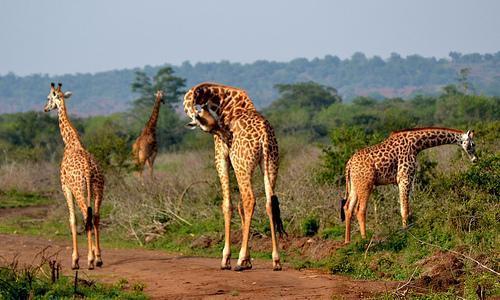How many giraffes are biting themselves?
Give a very brief answer. 1. 